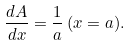<formula> <loc_0><loc_0><loc_500><loc_500>\frac { d A } { d x } = \frac { 1 } { a } \, ( x = a ) .</formula> 